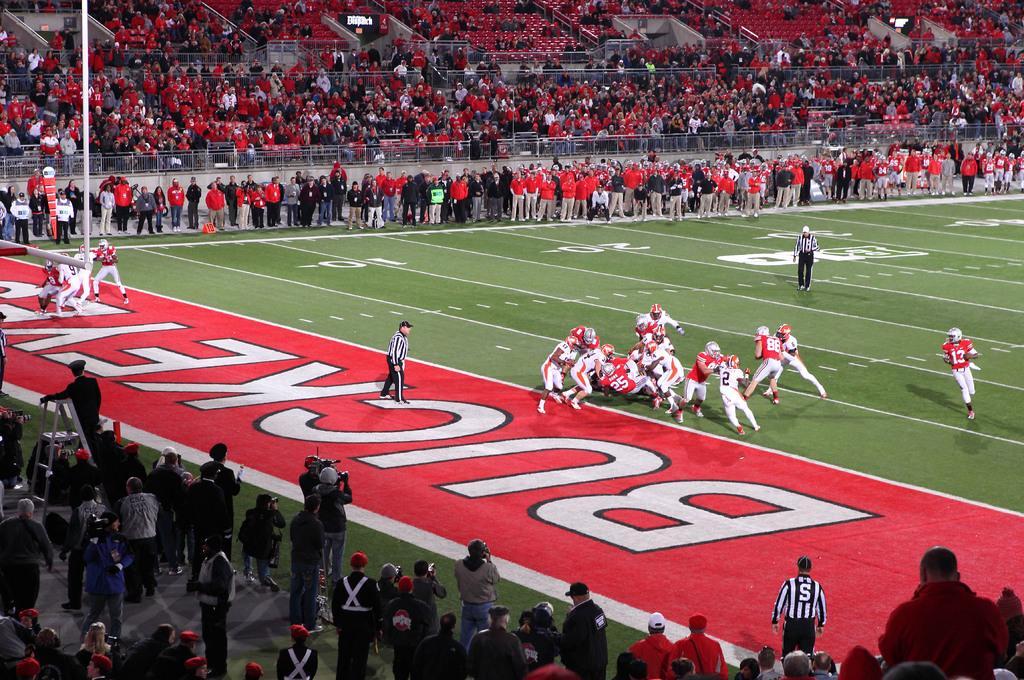How would you summarize this image in a sentence or two? In this picture we can observe rugby ground. There are some player in the ground. We can observe two referees. There are some people standing around the ground and there are some people sitting in the stadium. Most of them are wearing red color t-shirts. 